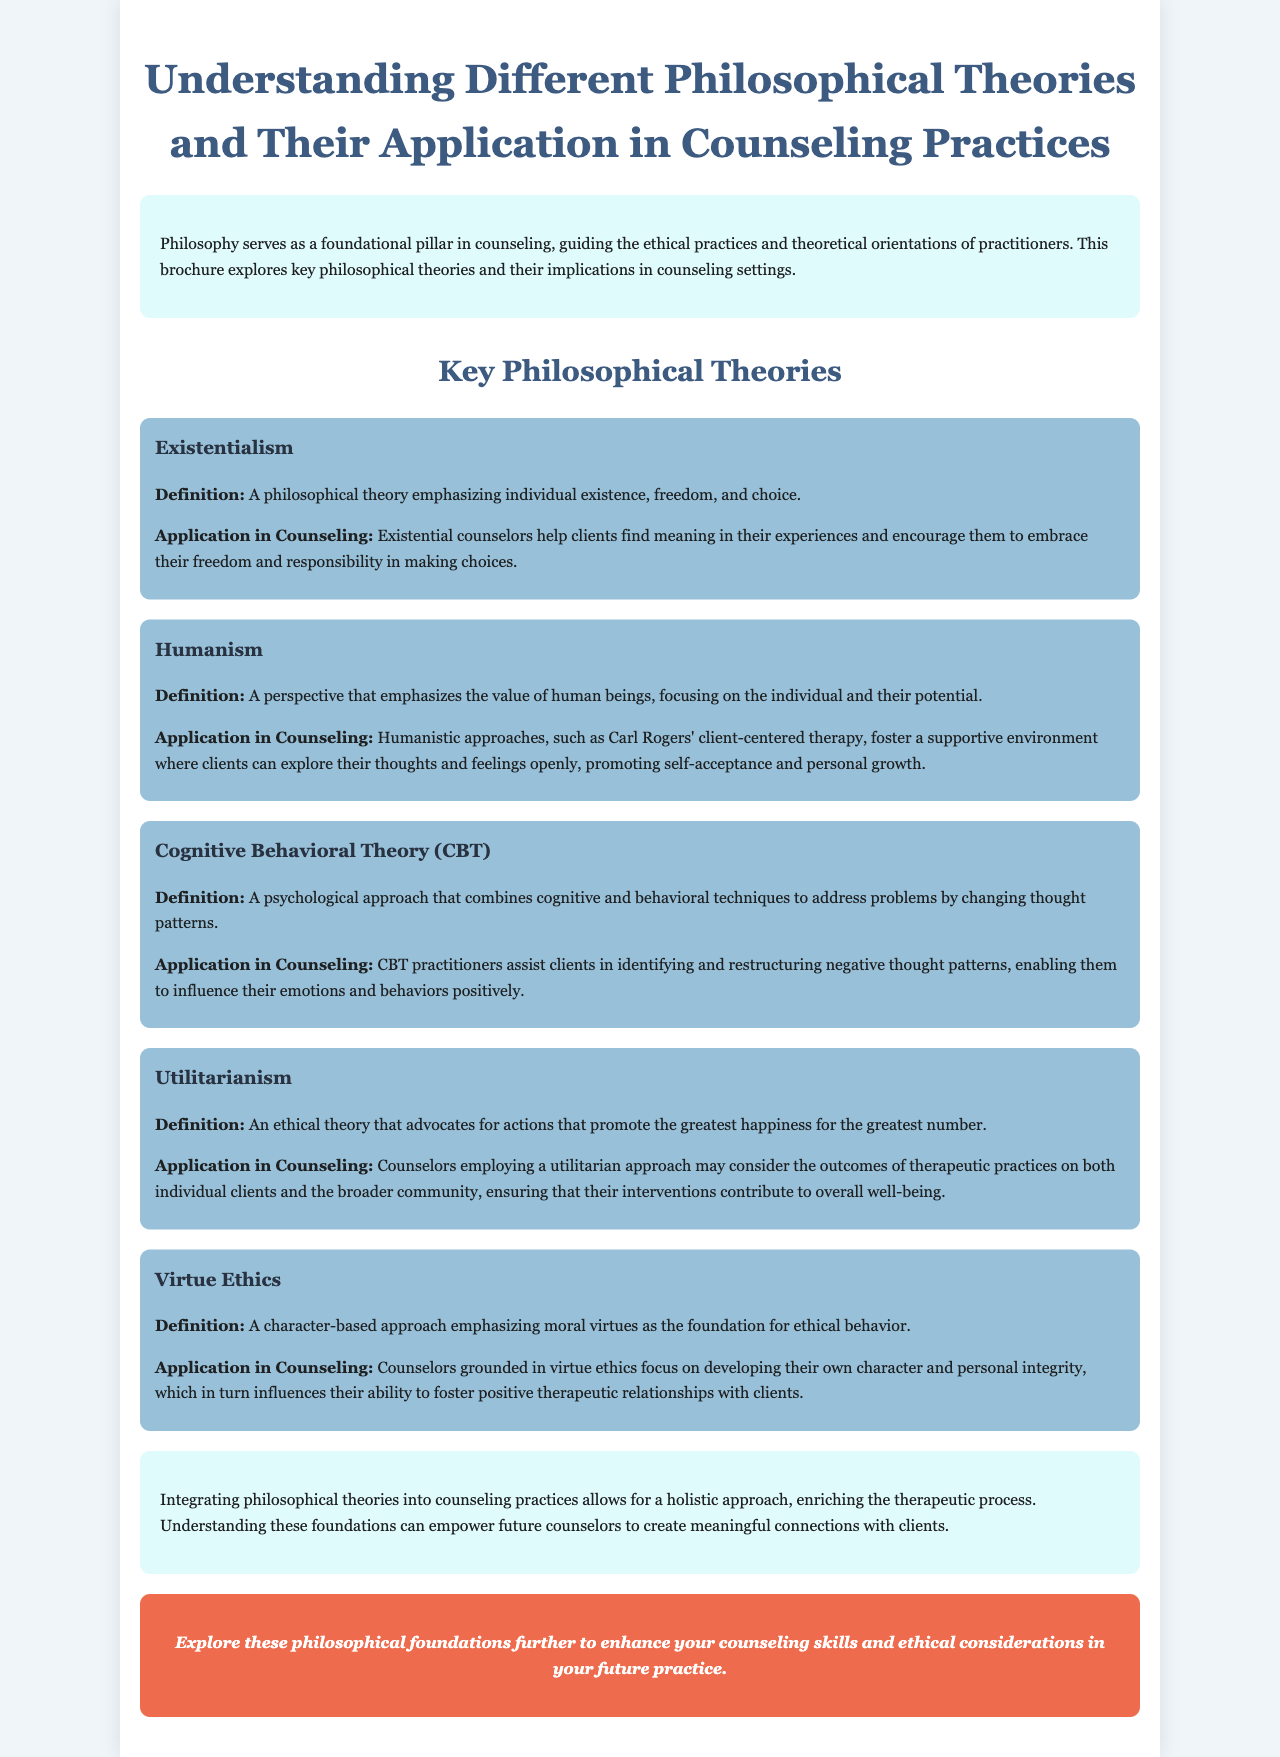What is the title of the brochure? The title is prominently displayed at the top of the document, summarizing its content.
Answer: Understanding Different Philosophical Theories and Their Application in Counseling Practices What does existentialism emphasize? The document defines existentialism in a clear and concise manner, focusing on its main themes.
Answer: Individual existence, freedom, and choice Name one application of humanistic approaches in counseling. The application section under humanism outlines the goals of this therapeutic perspective.
Answer: Promoting self-acceptance and personal growth What ethical theory advocates for actions promoting the greatest happiness? The brochure categorizes different philosophical theories, providing definitions and applications for each.
Answer: Utilitarianism Which therapy assists clients in restructuring negative thought patterns? The document highlights specific approaches under cognitive behavioral theory, indicating its methods.
Answer: Cognitive Behavioral Therapy (CBT) How many key philosophical theories are discussed? The section titled "Key Philosophical Theories" introduces the number of theories explored within the brochure.
Answer: Five What does virtue ethics focus on developing? The explanation of virtue ethics clarifies the primary focus of this philosophical approach in counseling.
Answer: Moral virtues What is the call to action at the end of the brochure? The CTA section encourages readers to further explore the topics discussed in the document.
Answer: Explore these philosophical foundations further 